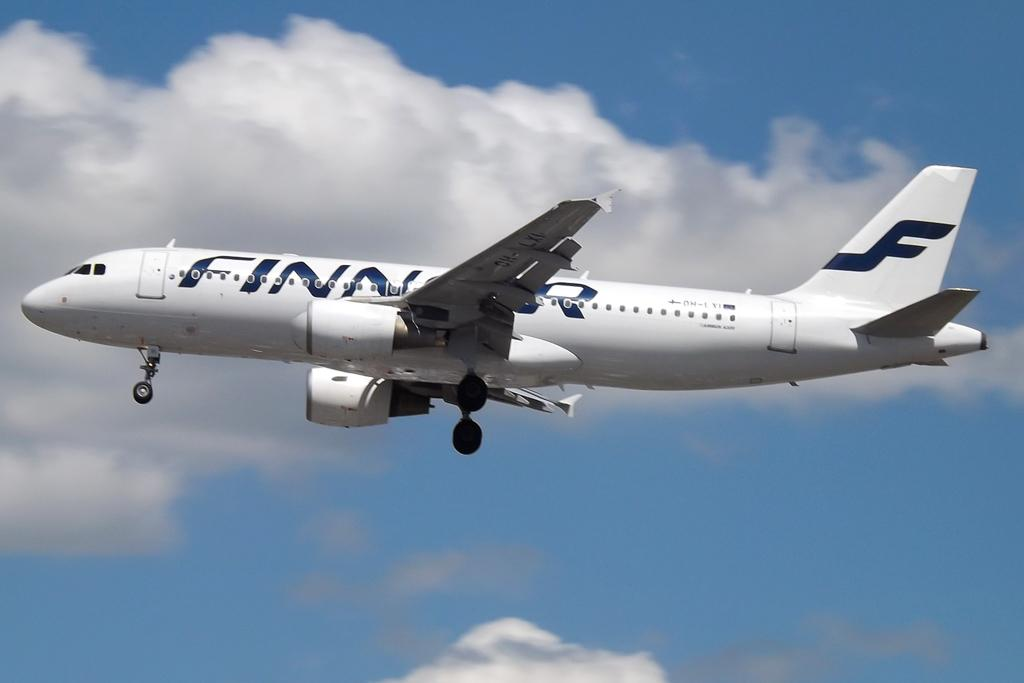<image>
Share a concise interpretation of the image provided. A white Finnair plane flying through clouds in the sky. 